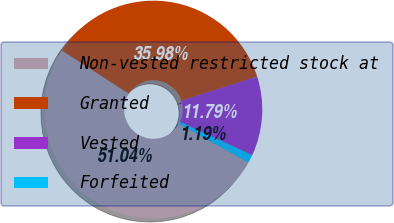Convert chart. <chart><loc_0><loc_0><loc_500><loc_500><pie_chart><fcel>Non-vested restricted stock at<fcel>Granted<fcel>Vested<fcel>Forfeited<nl><fcel>51.04%<fcel>35.98%<fcel>11.79%<fcel>1.19%<nl></chart> 